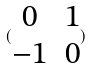Convert formula to latex. <formula><loc_0><loc_0><loc_500><loc_500>( \begin{matrix} 0 & 1 \\ - 1 & 0 \\ \end{matrix} )</formula> 